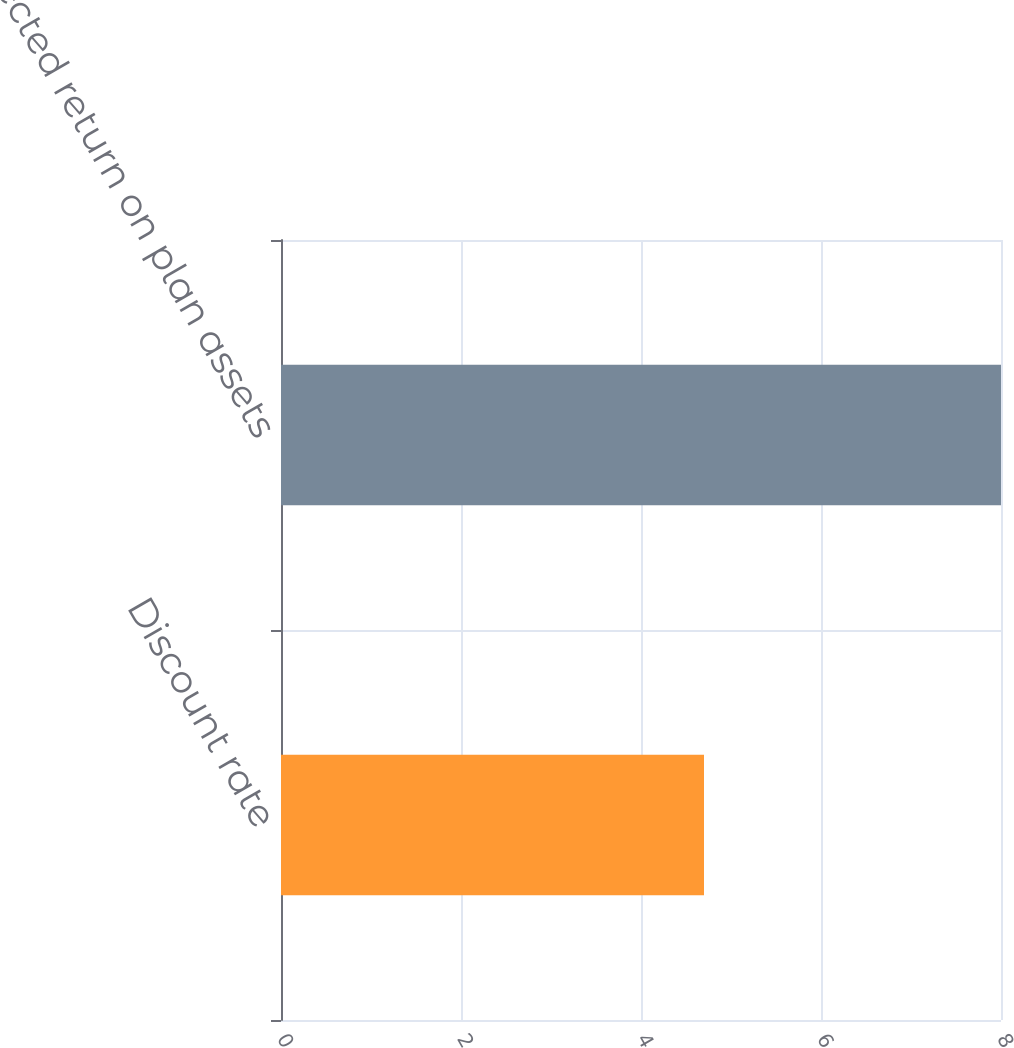Convert chart to OTSL. <chart><loc_0><loc_0><loc_500><loc_500><bar_chart><fcel>Discount rate<fcel>Expected return on plan assets<nl><fcel>4.7<fcel>8<nl></chart> 